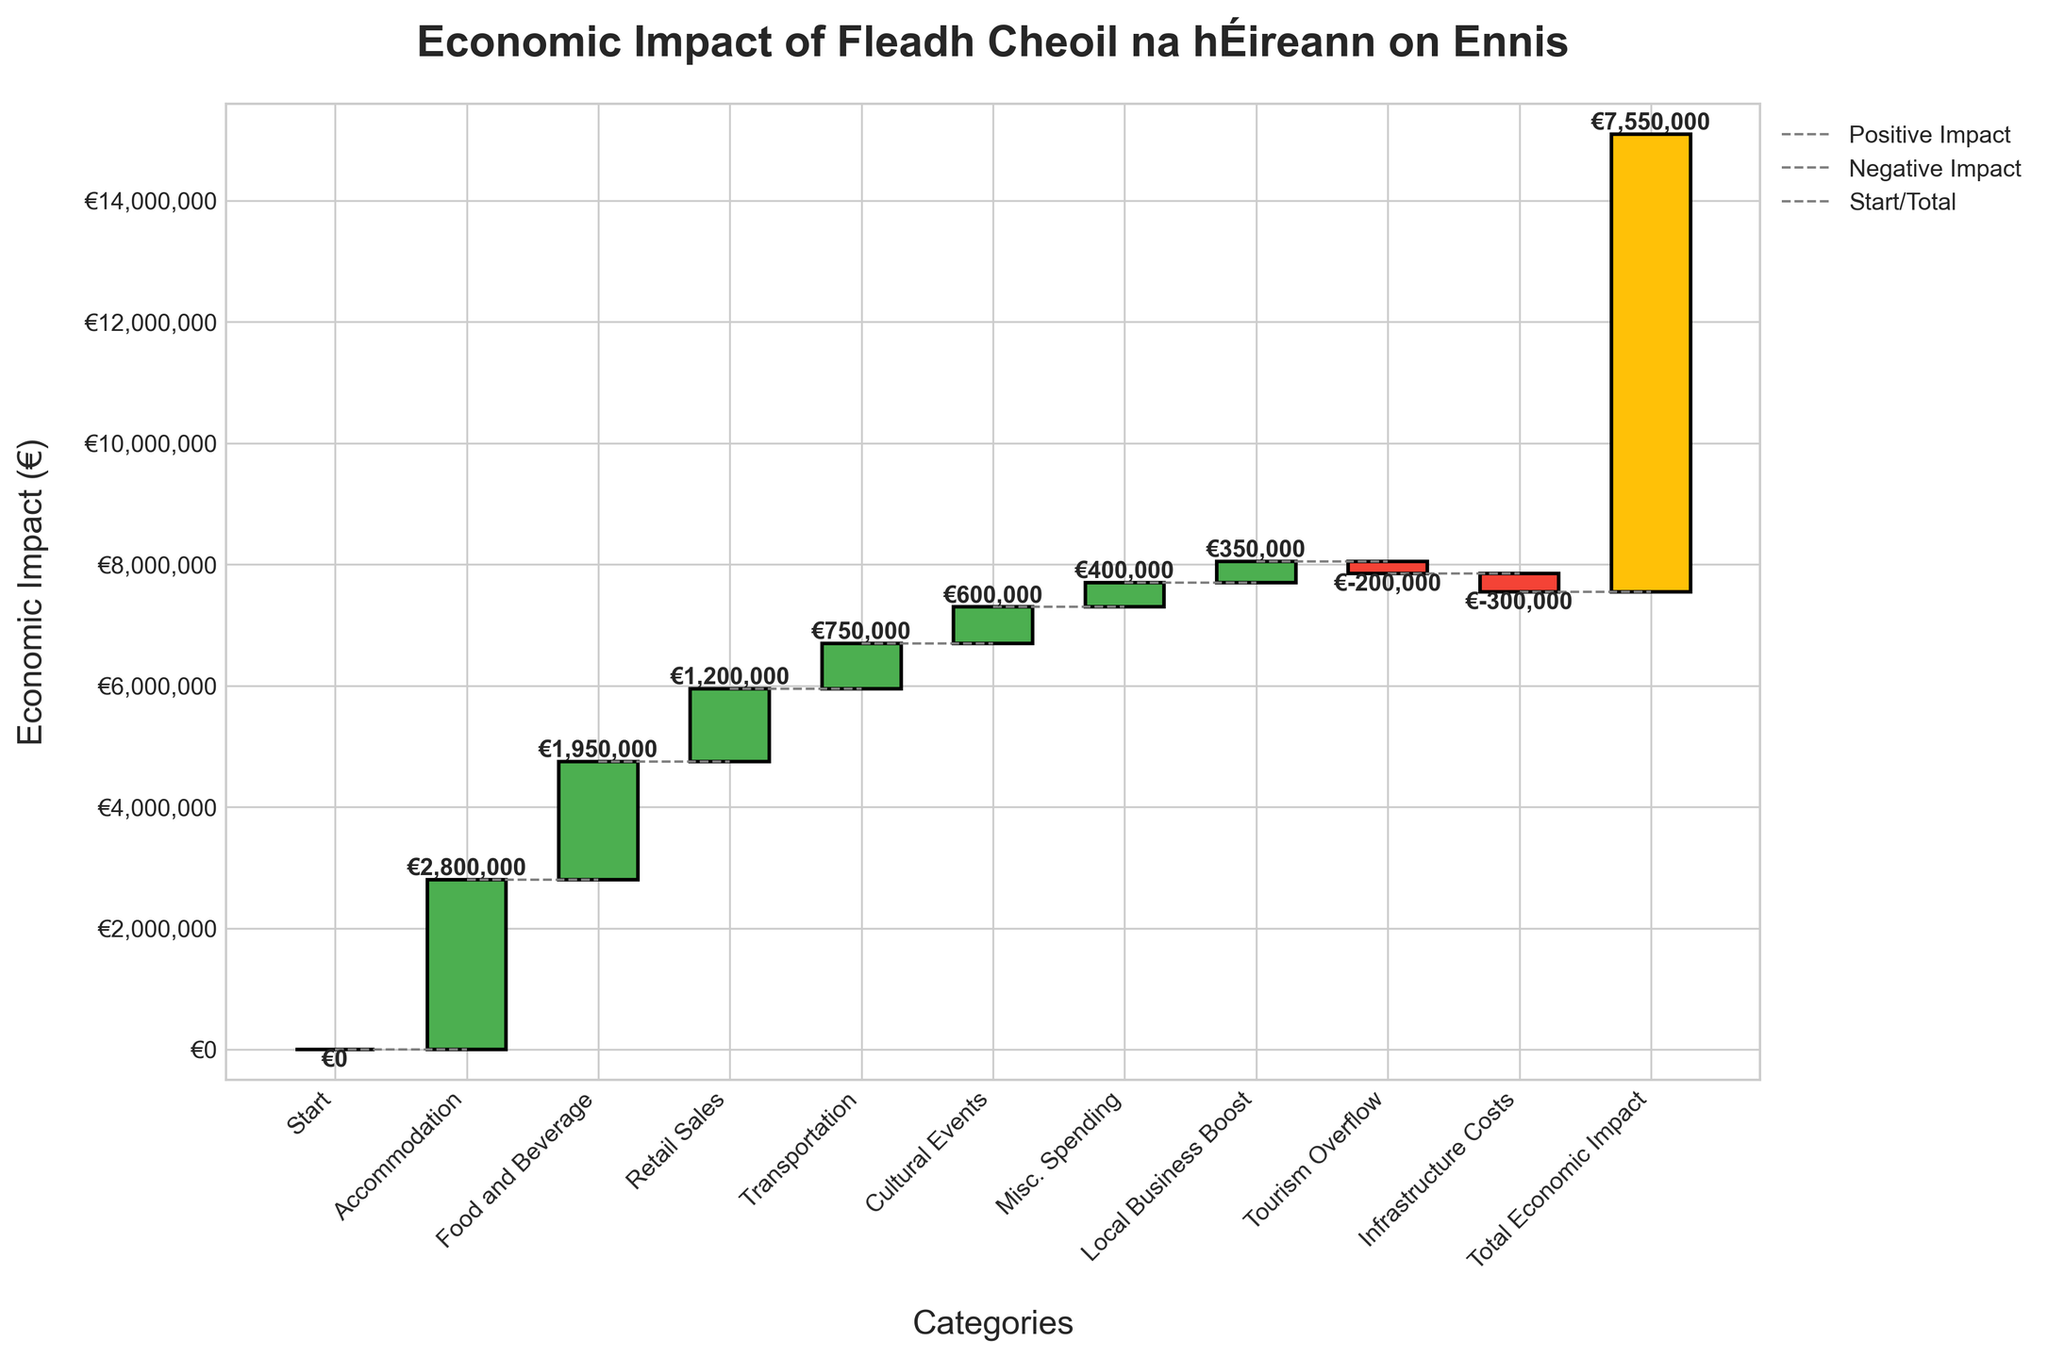What is the title of the chart? The title of the chart is prominently displayed at the top, indicating the main topic of the chart.
Answer: Economic Impact of Fleadh Cheoil na hÉireann on Ennis Which category generated the highest revenue? By observing the height of the bars, we can see that the 'Accommodation' category has the highest revenue.
Answer: Accommodation What is the total economic impact according to the chart? The total economic impact is shown at the end of the chart and highlighted with a different color for distinction.
Answer: €7,550,000 How much revenue did the 'Food and Beverage' sector generate? By looking at the 'Food and Beverage' bar on the chart and reading the value label, we find the revenue.
Answer: €1,950,000 Which category caused the largest negative impact? Among the categories with negative values, 'Infrastructure Costs' shows the largest negative impact as indicated by the bar height and value.
Answer: Infrastructure Costs What is the combined revenue from 'Retail Sales' and 'Transportation'? Adding the values of 'Retail Sales' (€1,200,000) and 'Transportation' (€750,000) to get the total.
Answer: €1,950,000 What is the net economic impact after considering 'Tourism Overflow' and 'Infrastructure Costs'? Subtracting the negative impacts of 'Tourism Overflow' (€-200,000) and 'Infrastructure Costs' (€-300,000) from the total revenue impact.
Answer: €-500,000 How does the contribution of 'Cultural Events' compare to 'Misc. Spending'? By comparing the height and value labels of the 'Cultural Events' and 'Misc. Spending' bars, we see that 'Cultural Events' generates more revenue.
Answer: Greater than What's the total positive revenue before deductions for negative impacts? Summing up all positive values before accounting for any negative impacts: Accommodation (€2,800,000) + Food and Beverage (€1,950,000) + Retail Sales (€1,200,000) + Transportation (€750,000) + Cultural Events (€600,000) + Misc. Spending (€400,000) + Local Business Boost (€350,000).
Answer: €8,050,000 What value does the first category after 'Start' represent? The first category after 'Start' is 'Accommodation', and its value is indicated by the corresponding bar.
Answer: €2,800,000 